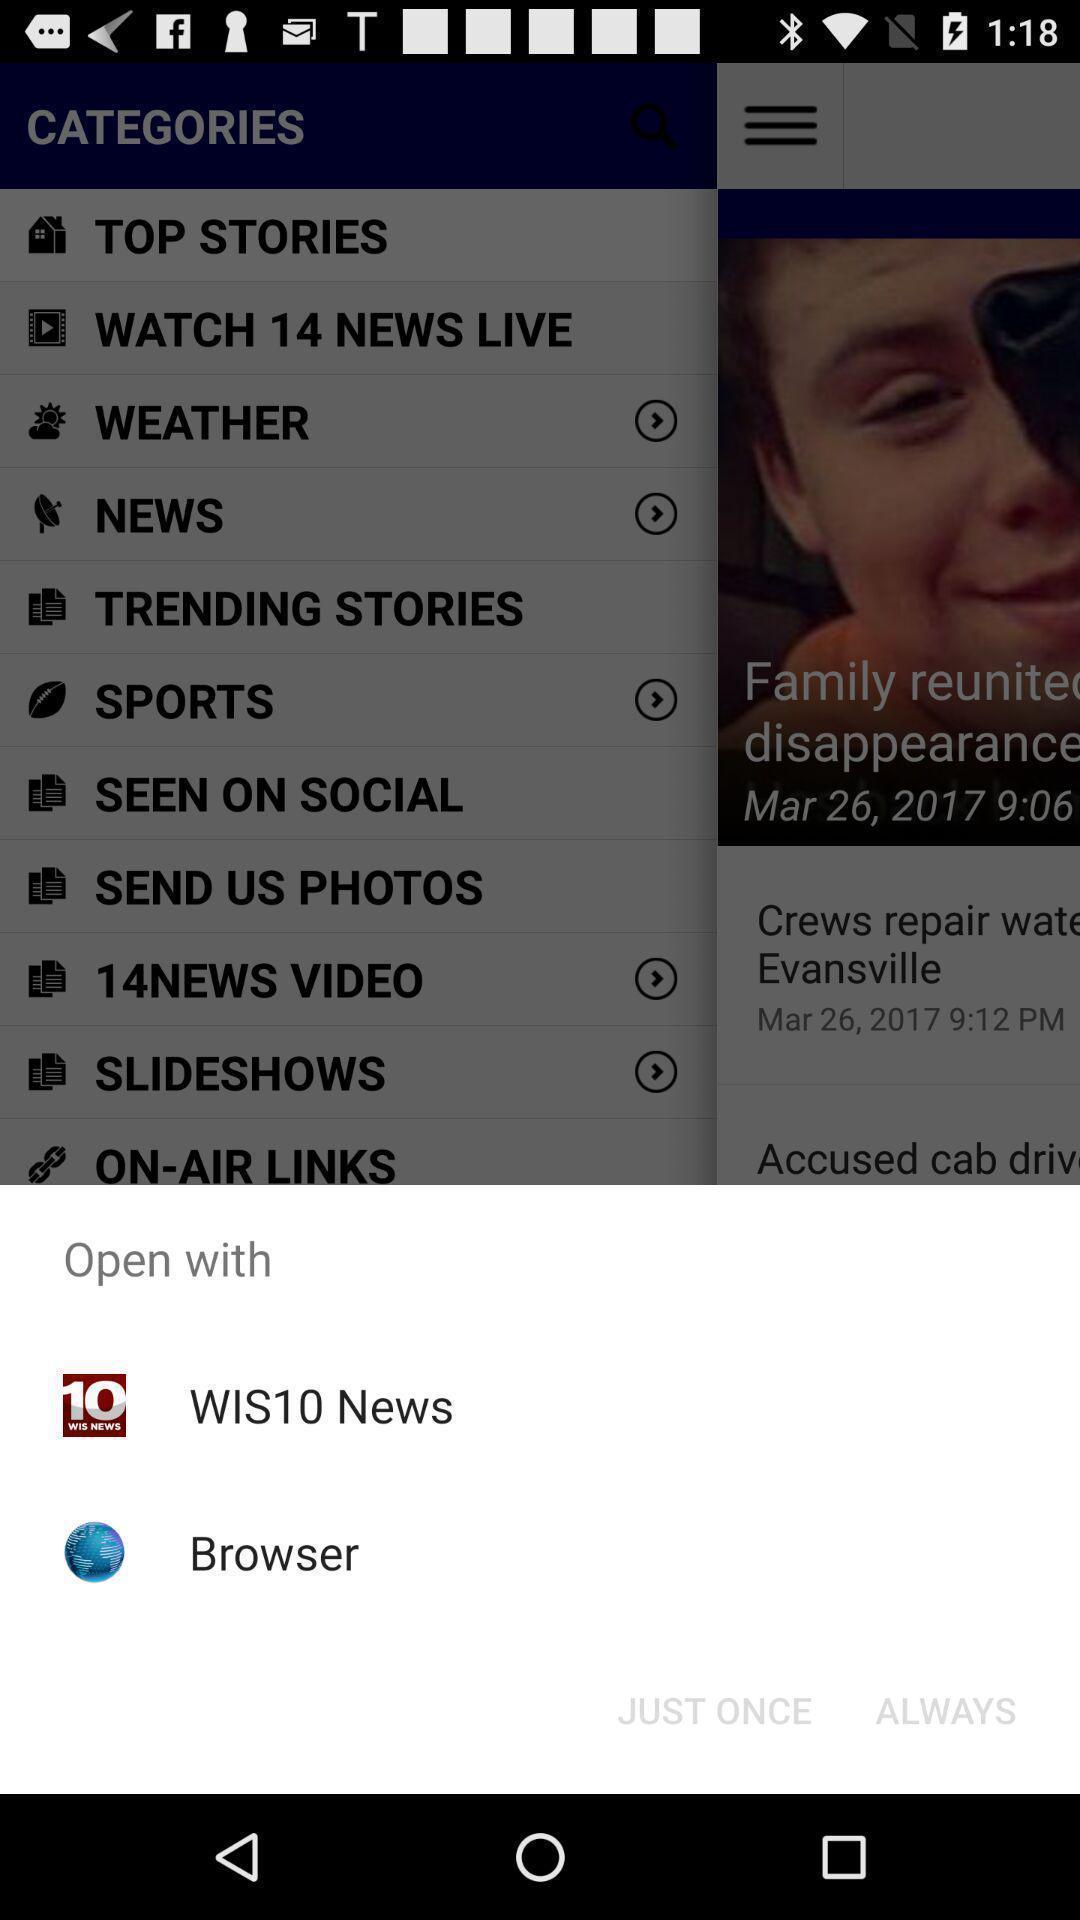Provide a description of this screenshot. Popup displaying open options. 